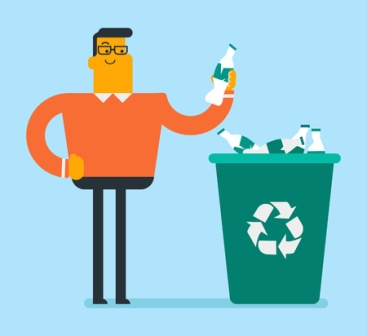What can you infer about the message being conveyed in this image? This image strongly suggests the importance of recycling and environmental responsibility. The man’s action of holding a bottle next to a recycling bin filled with similar bottles emphasizes that everyday actions like recycling can significantly impact our planet. The universal recycling symbol on the bin further reinforces the message of sustainability and environmental awareness. 